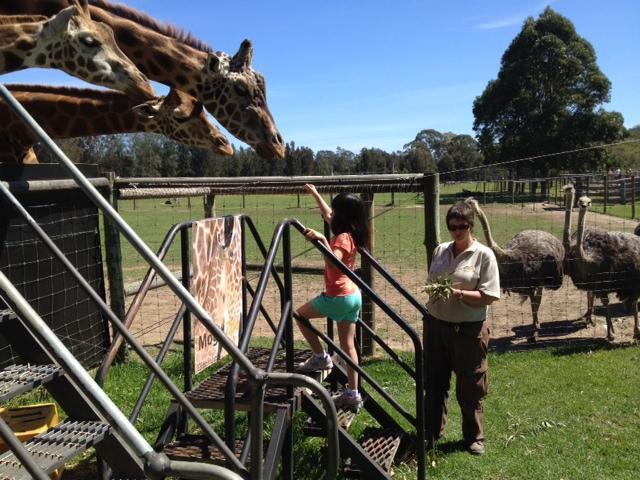Why is the short haired woman wearing a khaki shirt?
Indicate the correct response and explain using: 'Answer: answer
Rationale: rationale.'
Options: Fashion, staying cool, dress code, keeping warm. Answer: dress code.
Rationale: A khaki polo shirt worn with brown pants and boots looks like a uniform when combined with the name tag she is wearing. 